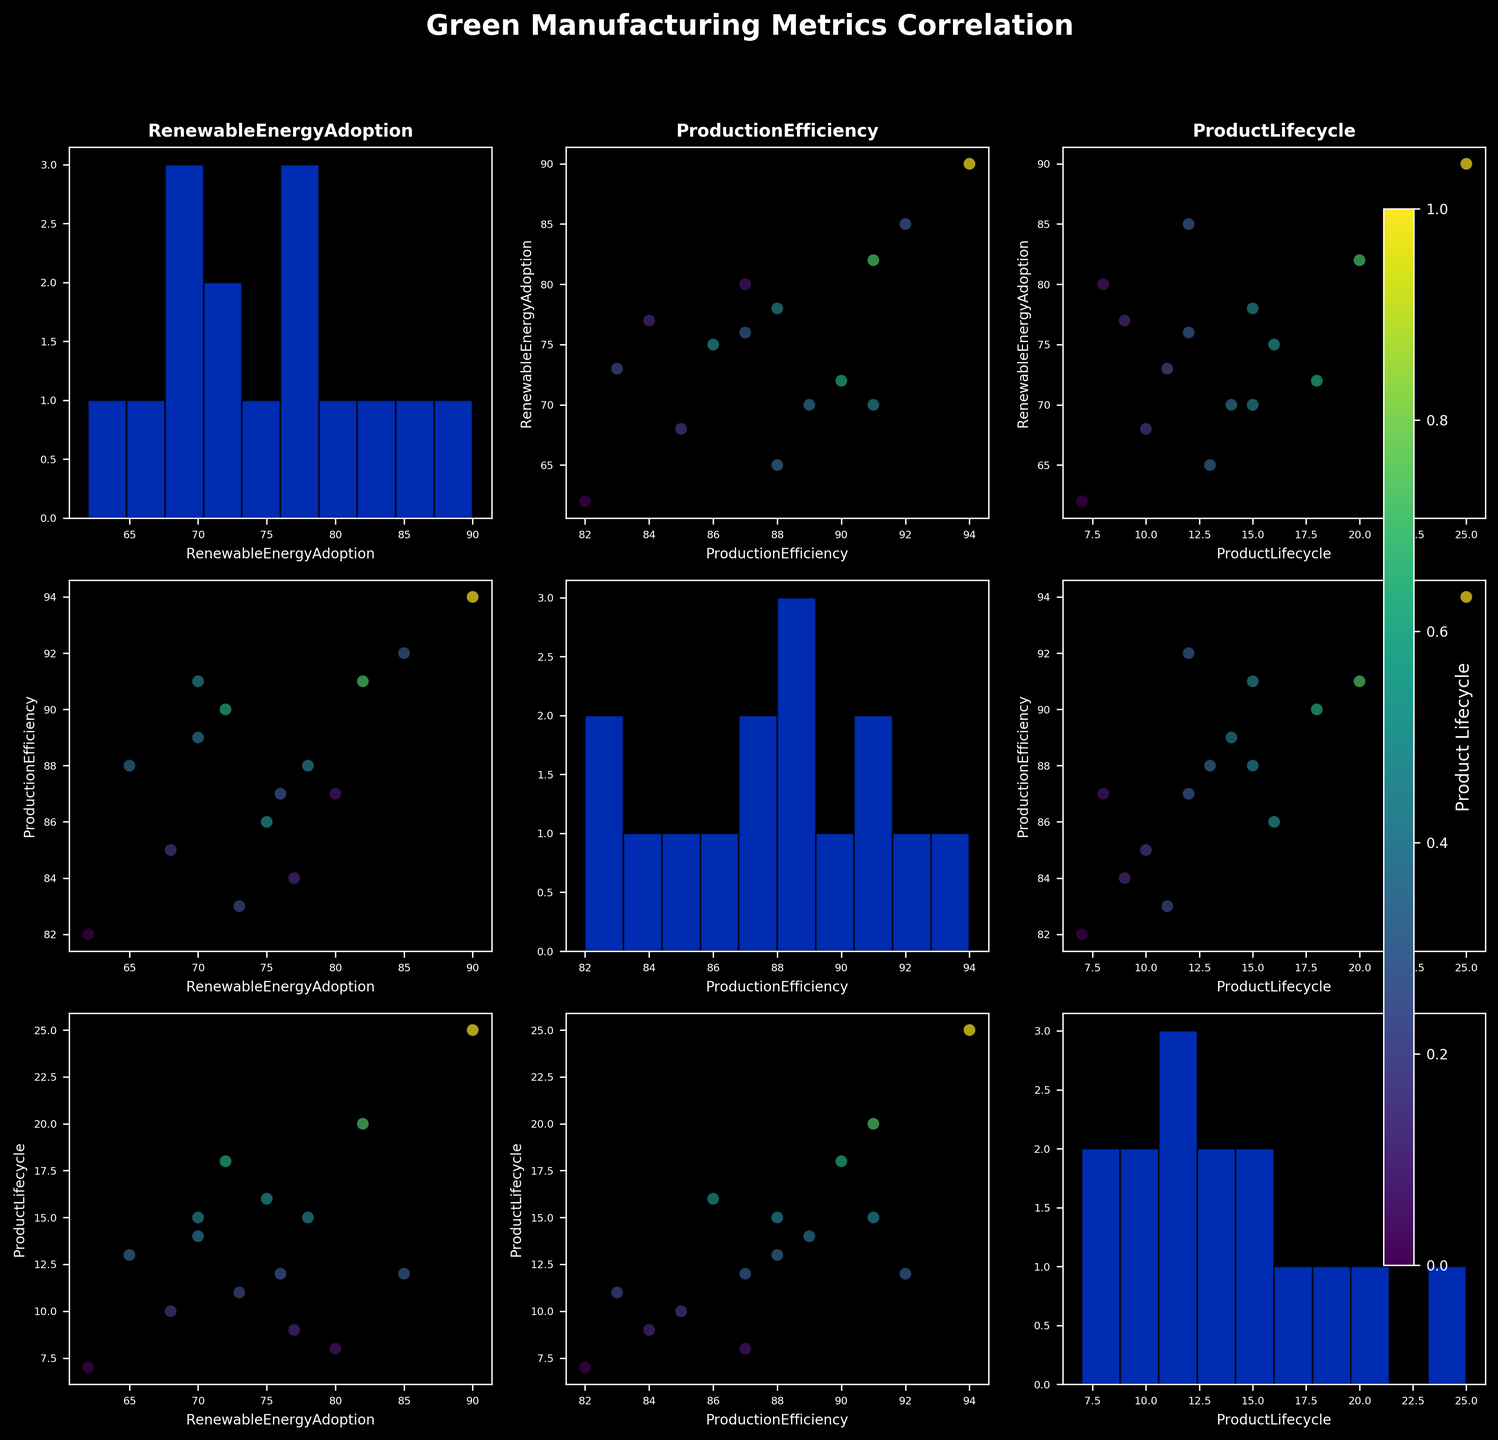What is the title of the scatterplot matrix? The title of the scatterplot matrix is prominently positioned at the top of the figure, providing an overview of what the plot represents.
Answer: Green Manufacturing Metrics Correlation What are the variables analyzed in this scatterplot matrix? The axes labels and titles on the histograms indicate the variables being analyzed.
Answer: Renewable Energy Adoption, Production Efficiency, and Product Lifecycle Which variable is shown on the color gradient? The color bar on the right side of the figure indicates the variable used for the color gradient.
Answer: Product Lifecycle How many companies are plotted in the scatterplots? By counting the total number of data points in any scatter plot or histogram, all representing companies, we can determine this.
Answer: 15 Does higher Renewable Energy Adoption correlate with longer Product Lifecycles? Observing the scatter plot with Renewable Energy Adoption on one axis and Product Lifecycle on the other, we infer the trend. Companies with darker colors (signifying longer lifecycles) seem to have higher Renewable Energy Adoption.
Answer: Yes Which company has the highest Production Efficiency, and what is their Renewable Energy Adoption value? By finding the data point at the maximum value on the Production Efficiency axis and noting the corresponding Renewable Energy Adoption value.
Answer: Vestas Wind Systems: 90 Are there any companies with both low Renewable Energy Adoption and low Production Efficiency? Checking the lower left sections of scatter plots between Renewable Energy Adoption and Production Efficiency, we look for any low-value data points.
Answer: Heineken: 62 in Renewable Energy Adoption, 82 in Production Efficiency Is there a general trend between Production Efficiency and Product Lifecycle observed in the scatterplots? By analyzing the scatterplot, where Production Efficiency is plotted on one axis and Product Lifecycle on the other, we observe the relationship pattern.
Answer: Generally positive How does IKEA's Renewable Energy Adoption compare to Tesla's? Locate the data points corresponding to IKEA and Tesla in the scatter plots and compare their Renewable Energy Adoption values.
Answer: Tesla: 85, IKEA: 80 What is the range of Production Efficiency observed across all companies? By looking at the x-axes of the Production Efficiency histograms or scatter plots, we identify the minimum and maximum values.
Answer: 82 to 94 